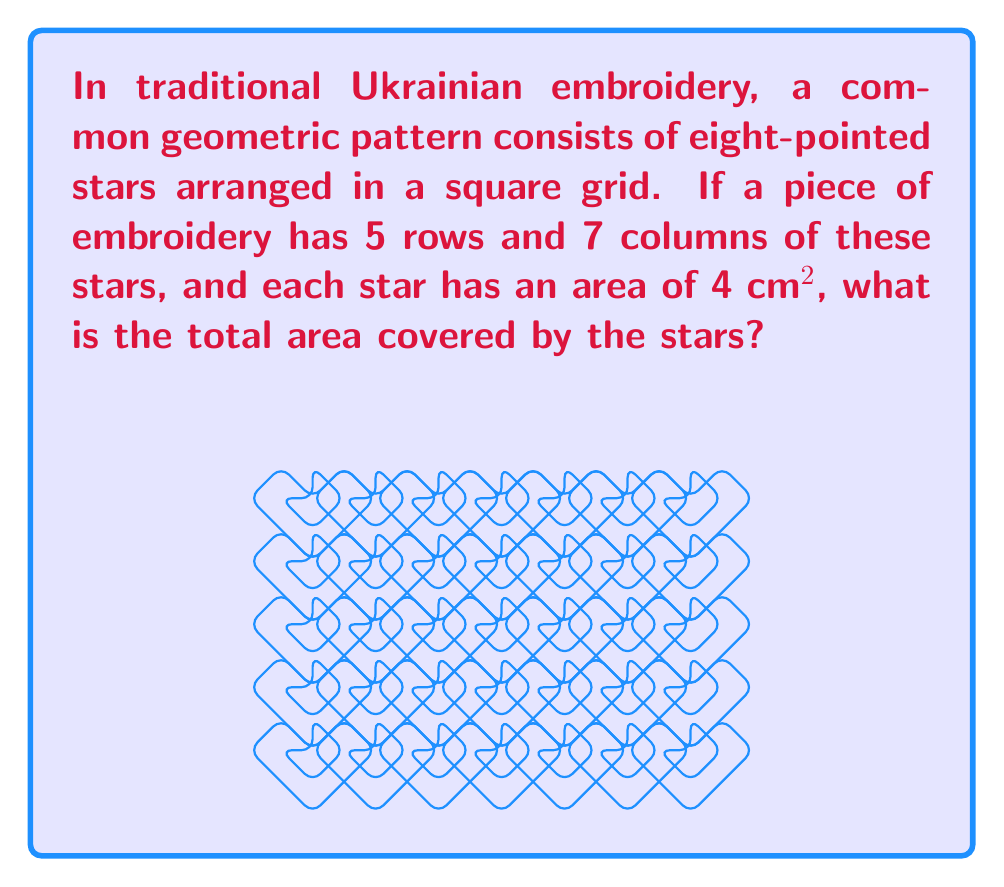Show me your answer to this math problem. Let's approach this step-by-step:

1) First, we need to count the total number of stars in the embroidery:
   - Number of rows = 5
   - Number of columns = 7
   - Total number of stars = $5 \times 7 = 35$

2) We're given that each star has an area of 4 cm²:
   - Area of one star = 4 cm²

3) To find the total area covered by the stars, we multiply the number of stars by the area of each star:
   
   $$\text{Total Area} = \text{Number of stars} \times \text{Area of one star}$$
   $$\text{Total Area} = 35 \times 4\text{ cm}^2$$
   $$\text{Total Area} = 140\text{ cm}^2$$

Thus, the total area covered by the stars in the embroidery is 140 cm².
Answer: 140 cm² 